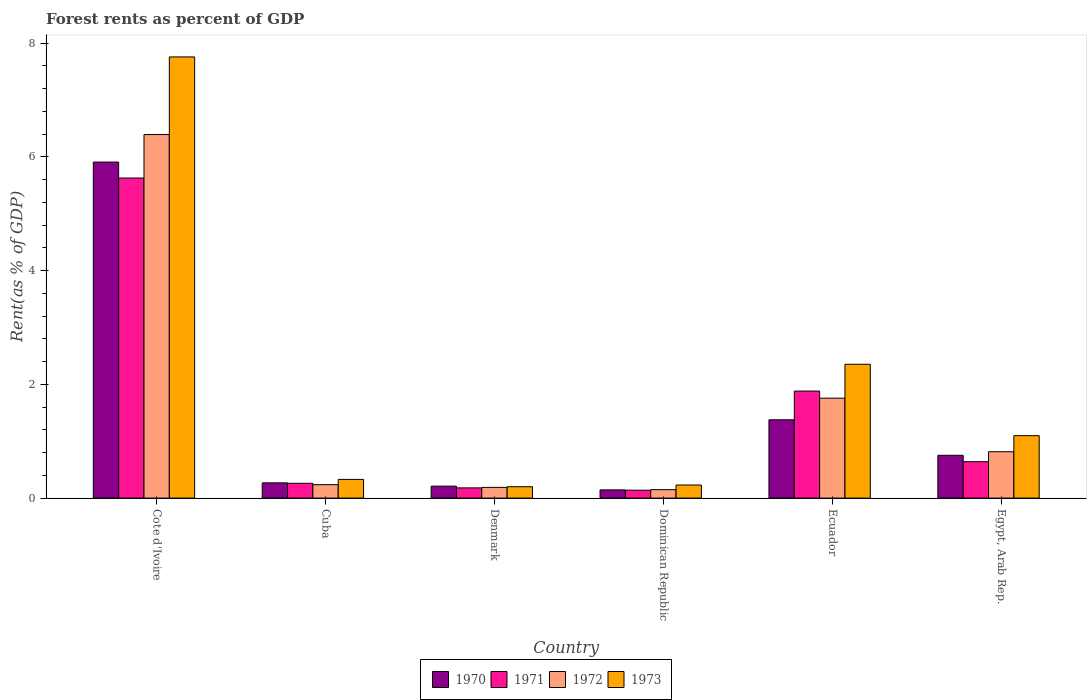How many different coloured bars are there?
Offer a very short reply. 4. How many bars are there on the 6th tick from the right?
Your answer should be very brief. 4. What is the label of the 5th group of bars from the left?
Offer a terse response. Ecuador. What is the forest rent in 1972 in Egypt, Arab Rep.?
Your answer should be compact. 0.82. Across all countries, what is the maximum forest rent in 1971?
Your answer should be compact. 5.63. Across all countries, what is the minimum forest rent in 1971?
Make the answer very short. 0.14. In which country was the forest rent in 1972 maximum?
Your answer should be very brief. Cote d'Ivoire. In which country was the forest rent in 1970 minimum?
Make the answer very short. Dominican Republic. What is the total forest rent in 1973 in the graph?
Provide a succinct answer. 11.97. What is the difference between the forest rent in 1972 in Dominican Republic and that in Ecuador?
Your response must be concise. -1.61. What is the difference between the forest rent in 1970 in Cote d'Ivoire and the forest rent in 1972 in Denmark?
Offer a very short reply. 5.72. What is the average forest rent in 1973 per country?
Your response must be concise. 1.99. What is the difference between the forest rent of/in 1970 and forest rent of/in 1971 in Dominican Republic?
Ensure brevity in your answer.  0.01. In how many countries, is the forest rent in 1972 greater than 5.2 %?
Your answer should be very brief. 1. What is the ratio of the forest rent in 1972 in Cote d'Ivoire to that in Dominican Republic?
Ensure brevity in your answer.  43.07. Is the difference between the forest rent in 1970 in Ecuador and Egypt, Arab Rep. greater than the difference between the forest rent in 1971 in Ecuador and Egypt, Arab Rep.?
Provide a short and direct response. No. What is the difference between the highest and the second highest forest rent in 1973?
Your answer should be very brief. -1.26. What is the difference between the highest and the lowest forest rent in 1972?
Offer a very short reply. 6.25. In how many countries, is the forest rent in 1972 greater than the average forest rent in 1972 taken over all countries?
Offer a very short reply. 2. Is the sum of the forest rent in 1971 in Cuba and Dominican Republic greater than the maximum forest rent in 1972 across all countries?
Your answer should be compact. No. Is it the case that in every country, the sum of the forest rent in 1973 and forest rent in 1970 is greater than the sum of forest rent in 1972 and forest rent in 1971?
Keep it short and to the point. No. What does the 4th bar from the left in Cote d'Ivoire represents?
Ensure brevity in your answer.  1973. What does the 1st bar from the right in Egypt, Arab Rep. represents?
Your answer should be compact. 1973. How many bars are there?
Offer a terse response. 24. Are all the bars in the graph horizontal?
Make the answer very short. No. How many countries are there in the graph?
Ensure brevity in your answer.  6. What is the difference between two consecutive major ticks on the Y-axis?
Offer a very short reply. 2. Are the values on the major ticks of Y-axis written in scientific E-notation?
Offer a very short reply. No. Does the graph contain any zero values?
Make the answer very short. No. Does the graph contain grids?
Ensure brevity in your answer.  No. How many legend labels are there?
Keep it short and to the point. 4. How are the legend labels stacked?
Offer a very short reply. Horizontal. What is the title of the graph?
Provide a short and direct response. Forest rents as percent of GDP. What is the label or title of the Y-axis?
Your answer should be very brief. Rent(as % of GDP). What is the Rent(as % of GDP) in 1970 in Cote d'Ivoire?
Your response must be concise. 5.91. What is the Rent(as % of GDP) of 1971 in Cote d'Ivoire?
Your response must be concise. 5.63. What is the Rent(as % of GDP) of 1972 in Cote d'Ivoire?
Make the answer very short. 6.39. What is the Rent(as % of GDP) in 1973 in Cote d'Ivoire?
Your response must be concise. 7.76. What is the Rent(as % of GDP) in 1970 in Cuba?
Give a very brief answer. 0.27. What is the Rent(as % of GDP) in 1971 in Cuba?
Your response must be concise. 0.26. What is the Rent(as % of GDP) of 1972 in Cuba?
Ensure brevity in your answer.  0.24. What is the Rent(as % of GDP) of 1973 in Cuba?
Offer a very short reply. 0.33. What is the Rent(as % of GDP) in 1970 in Denmark?
Make the answer very short. 0.21. What is the Rent(as % of GDP) of 1971 in Denmark?
Your response must be concise. 0.18. What is the Rent(as % of GDP) of 1972 in Denmark?
Offer a very short reply. 0.19. What is the Rent(as % of GDP) in 1973 in Denmark?
Offer a very short reply. 0.2. What is the Rent(as % of GDP) in 1970 in Dominican Republic?
Give a very brief answer. 0.14. What is the Rent(as % of GDP) in 1971 in Dominican Republic?
Provide a succinct answer. 0.14. What is the Rent(as % of GDP) of 1972 in Dominican Republic?
Give a very brief answer. 0.15. What is the Rent(as % of GDP) in 1973 in Dominican Republic?
Offer a very short reply. 0.23. What is the Rent(as % of GDP) of 1970 in Ecuador?
Provide a short and direct response. 1.38. What is the Rent(as % of GDP) of 1971 in Ecuador?
Your answer should be compact. 1.88. What is the Rent(as % of GDP) in 1972 in Ecuador?
Keep it short and to the point. 1.76. What is the Rent(as % of GDP) in 1973 in Ecuador?
Provide a succinct answer. 2.35. What is the Rent(as % of GDP) in 1970 in Egypt, Arab Rep.?
Provide a succinct answer. 0.75. What is the Rent(as % of GDP) of 1971 in Egypt, Arab Rep.?
Offer a very short reply. 0.64. What is the Rent(as % of GDP) in 1972 in Egypt, Arab Rep.?
Your response must be concise. 0.82. What is the Rent(as % of GDP) of 1973 in Egypt, Arab Rep.?
Provide a succinct answer. 1.1. Across all countries, what is the maximum Rent(as % of GDP) of 1970?
Give a very brief answer. 5.91. Across all countries, what is the maximum Rent(as % of GDP) of 1971?
Your response must be concise. 5.63. Across all countries, what is the maximum Rent(as % of GDP) in 1972?
Make the answer very short. 6.39. Across all countries, what is the maximum Rent(as % of GDP) of 1973?
Your response must be concise. 7.76. Across all countries, what is the minimum Rent(as % of GDP) in 1970?
Give a very brief answer. 0.14. Across all countries, what is the minimum Rent(as % of GDP) of 1971?
Your answer should be compact. 0.14. Across all countries, what is the minimum Rent(as % of GDP) of 1972?
Provide a short and direct response. 0.15. Across all countries, what is the minimum Rent(as % of GDP) in 1973?
Your response must be concise. 0.2. What is the total Rent(as % of GDP) of 1970 in the graph?
Give a very brief answer. 8.66. What is the total Rent(as % of GDP) in 1971 in the graph?
Ensure brevity in your answer.  8.73. What is the total Rent(as % of GDP) in 1972 in the graph?
Your answer should be compact. 9.54. What is the total Rent(as % of GDP) in 1973 in the graph?
Provide a short and direct response. 11.97. What is the difference between the Rent(as % of GDP) in 1970 in Cote d'Ivoire and that in Cuba?
Provide a short and direct response. 5.64. What is the difference between the Rent(as % of GDP) of 1971 in Cote d'Ivoire and that in Cuba?
Give a very brief answer. 5.37. What is the difference between the Rent(as % of GDP) in 1972 in Cote d'Ivoire and that in Cuba?
Offer a very short reply. 6.16. What is the difference between the Rent(as % of GDP) of 1973 in Cote d'Ivoire and that in Cuba?
Give a very brief answer. 7.43. What is the difference between the Rent(as % of GDP) of 1970 in Cote d'Ivoire and that in Denmark?
Offer a terse response. 5.7. What is the difference between the Rent(as % of GDP) of 1971 in Cote d'Ivoire and that in Denmark?
Your answer should be very brief. 5.45. What is the difference between the Rent(as % of GDP) of 1972 in Cote d'Ivoire and that in Denmark?
Make the answer very short. 6.21. What is the difference between the Rent(as % of GDP) in 1973 in Cote d'Ivoire and that in Denmark?
Your response must be concise. 7.56. What is the difference between the Rent(as % of GDP) of 1970 in Cote d'Ivoire and that in Dominican Republic?
Ensure brevity in your answer.  5.77. What is the difference between the Rent(as % of GDP) of 1971 in Cote d'Ivoire and that in Dominican Republic?
Give a very brief answer. 5.49. What is the difference between the Rent(as % of GDP) in 1972 in Cote d'Ivoire and that in Dominican Republic?
Your answer should be compact. 6.25. What is the difference between the Rent(as % of GDP) in 1973 in Cote d'Ivoire and that in Dominican Republic?
Ensure brevity in your answer.  7.53. What is the difference between the Rent(as % of GDP) in 1970 in Cote d'Ivoire and that in Ecuador?
Provide a succinct answer. 4.53. What is the difference between the Rent(as % of GDP) in 1971 in Cote d'Ivoire and that in Ecuador?
Ensure brevity in your answer.  3.75. What is the difference between the Rent(as % of GDP) in 1972 in Cote d'Ivoire and that in Ecuador?
Ensure brevity in your answer.  4.64. What is the difference between the Rent(as % of GDP) of 1973 in Cote d'Ivoire and that in Ecuador?
Your response must be concise. 5.41. What is the difference between the Rent(as % of GDP) in 1970 in Cote d'Ivoire and that in Egypt, Arab Rep.?
Offer a terse response. 5.16. What is the difference between the Rent(as % of GDP) in 1971 in Cote d'Ivoire and that in Egypt, Arab Rep.?
Ensure brevity in your answer.  4.99. What is the difference between the Rent(as % of GDP) of 1972 in Cote d'Ivoire and that in Egypt, Arab Rep.?
Provide a succinct answer. 5.58. What is the difference between the Rent(as % of GDP) in 1973 in Cote d'Ivoire and that in Egypt, Arab Rep.?
Provide a short and direct response. 6.66. What is the difference between the Rent(as % of GDP) in 1970 in Cuba and that in Denmark?
Your answer should be very brief. 0.06. What is the difference between the Rent(as % of GDP) of 1971 in Cuba and that in Denmark?
Offer a terse response. 0.08. What is the difference between the Rent(as % of GDP) in 1972 in Cuba and that in Denmark?
Give a very brief answer. 0.05. What is the difference between the Rent(as % of GDP) of 1973 in Cuba and that in Denmark?
Make the answer very short. 0.13. What is the difference between the Rent(as % of GDP) of 1970 in Cuba and that in Dominican Republic?
Provide a succinct answer. 0.12. What is the difference between the Rent(as % of GDP) in 1971 in Cuba and that in Dominican Republic?
Provide a short and direct response. 0.12. What is the difference between the Rent(as % of GDP) in 1972 in Cuba and that in Dominican Republic?
Ensure brevity in your answer.  0.09. What is the difference between the Rent(as % of GDP) of 1973 in Cuba and that in Dominican Republic?
Provide a short and direct response. 0.1. What is the difference between the Rent(as % of GDP) of 1970 in Cuba and that in Ecuador?
Your answer should be compact. -1.11. What is the difference between the Rent(as % of GDP) in 1971 in Cuba and that in Ecuador?
Offer a very short reply. -1.62. What is the difference between the Rent(as % of GDP) of 1972 in Cuba and that in Ecuador?
Keep it short and to the point. -1.52. What is the difference between the Rent(as % of GDP) in 1973 in Cuba and that in Ecuador?
Ensure brevity in your answer.  -2.03. What is the difference between the Rent(as % of GDP) in 1970 in Cuba and that in Egypt, Arab Rep.?
Your response must be concise. -0.48. What is the difference between the Rent(as % of GDP) of 1971 in Cuba and that in Egypt, Arab Rep.?
Your response must be concise. -0.38. What is the difference between the Rent(as % of GDP) of 1972 in Cuba and that in Egypt, Arab Rep.?
Offer a very short reply. -0.58. What is the difference between the Rent(as % of GDP) in 1973 in Cuba and that in Egypt, Arab Rep.?
Ensure brevity in your answer.  -0.77. What is the difference between the Rent(as % of GDP) in 1970 in Denmark and that in Dominican Republic?
Offer a very short reply. 0.07. What is the difference between the Rent(as % of GDP) of 1971 in Denmark and that in Dominican Republic?
Your answer should be very brief. 0.04. What is the difference between the Rent(as % of GDP) in 1972 in Denmark and that in Dominican Republic?
Offer a very short reply. 0.04. What is the difference between the Rent(as % of GDP) in 1973 in Denmark and that in Dominican Republic?
Keep it short and to the point. -0.03. What is the difference between the Rent(as % of GDP) of 1970 in Denmark and that in Ecuador?
Your answer should be compact. -1.17. What is the difference between the Rent(as % of GDP) of 1971 in Denmark and that in Ecuador?
Offer a terse response. -1.7. What is the difference between the Rent(as % of GDP) in 1972 in Denmark and that in Ecuador?
Make the answer very short. -1.57. What is the difference between the Rent(as % of GDP) of 1973 in Denmark and that in Ecuador?
Your answer should be very brief. -2.15. What is the difference between the Rent(as % of GDP) in 1970 in Denmark and that in Egypt, Arab Rep.?
Give a very brief answer. -0.54. What is the difference between the Rent(as % of GDP) of 1971 in Denmark and that in Egypt, Arab Rep.?
Your response must be concise. -0.46. What is the difference between the Rent(as % of GDP) of 1972 in Denmark and that in Egypt, Arab Rep.?
Offer a terse response. -0.63. What is the difference between the Rent(as % of GDP) in 1973 in Denmark and that in Egypt, Arab Rep.?
Offer a terse response. -0.9. What is the difference between the Rent(as % of GDP) of 1970 in Dominican Republic and that in Ecuador?
Provide a short and direct response. -1.23. What is the difference between the Rent(as % of GDP) of 1971 in Dominican Republic and that in Ecuador?
Your answer should be compact. -1.74. What is the difference between the Rent(as % of GDP) in 1972 in Dominican Republic and that in Ecuador?
Your answer should be very brief. -1.61. What is the difference between the Rent(as % of GDP) in 1973 in Dominican Republic and that in Ecuador?
Your answer should be compact. -2.12. What is the difference between the Rent(as % of GDP) in 1970 in Dominican Republic and that in Egypt, Arab Rep.?
Your response must be concise. -0.61. What is the difference between the Rent(as % of GDP) of 1971 in Dominican Republic and that in Egypt, Arab Rep.?
Provide a short and direct response. -0.5. What is the difference between the Rent(as % of GDP) of 1972 in Dominican Republic and that in Egypt, Arab Rep.?
Your response must be concise. -0.67. What is the difference between the Rent(as % of GDP) of 1973 in Dominican Republic and that in Egypt, Arab Rep.?
Your answer should be very brief. -0.87. What is the difference between the Rent(as % of GDP) of 1970 in Ecuador and that in Egypt, Arab Rep.?
Your answer should be compact. 0.62. What is the difference between the Rent(as % of GDP) of 1971 in Ecuador and that in Egypt, Arab Rep.?
Provide a succinct answer. 1.24. What is the difference between the Rent(as % of GDP) in 1972 in Ecuador and that in Egypt, Arab Rep.?
Keep it short and to the point. 0.94. What is the difference between the Rent(as % of GDP) of 1973 in Ecuador and that in Egypt, Arab Rep.?
Offer a very short reply. 1.26. What is the difference between the Rent(as % of GDP) in 1970 in Cote d'Ivoire and the Rent(as % of GDP) in 1971 in Cuba?
Give a very brief answer. 5.65. What is the difference between the Rent(as % of GDP) of 1970 in Cote d'Ivoire and the Rent(as % of GDP) of 1972 in Cuba?
Offer a terse response. 5.67. What is the difference between the Rent(as % of GDP) in 1970 in Cote d'Ivoire and the Rent(as % of GDP) in 1973 in Cuba?
Offer a terse response. 5.58. What is the difference between the Rent(as % of GDP) of 1971 in Cote d'Ivoire and the Rent(as % of GDP) of 1972 in Cuba?
Your answer should be compact. 5.39. What is the difference between the Rent(as % of GDP) of 1971 in Cote d'Ivoire and the Rent(as % of GDP) of 1973 in Cuba?
Your answer should be compact. 5.3. What is the difference between the Rent(as % of GDP) in 1972 in Cote d'Ivoire and the Rent(as % of GDP) in 1973 in Cuba?
Make the answer very short. 6.07. What is the difference between the Rent(as % of GDP) in 1970 in Cote d'Ivoire and the Rent(as % of GDP) in 1971 in Denmark?
Your answer should be very brief. 5.73. What is the difference between the Rent(as % of GDP) of 1970 in Cote d'Ivoire and the Rent(as % of GDP) of 1972 in Denmark?
Provide a succinct answer. 5.72. What is the difference between the Rent(as % of GDP) in 1970 in Cote d'Ivoire and the Rent(as % of GDP) in 1973 in Denmark?
Your answer should be compact. 5.71. What is the difference between the Rent(as % of GDP) of 1971 in Cote d'Ivoire and the Rent(as % of GDP) of 1972 in Denmark?
Keep it short and to the point. 5.44. What is the difference between the Rent(as % of GDP) in 1971 in Cote d'Ivoire and the Rent(as % of GDP) in 1973 in Denmark?
Your response must be concise. 5.43. What is the difference between the Rent(as % of GDP) of 1972 in Cote d'Ivoire and the Rent(as % of GDP) of 1973 in Denmark?
Offer a very short reply. 6.19. What is the difference between the Rent(as % of GDP) in 1970 in Cote d'Ivoire and the Rent(as % of GDP) in 1971 in Dominican Republic?
Keep it short and to the point. 5.77. What is the difference between the Rent(as % of GDP) in 1970 in Cote d'Ivoire and the Rent(as % of GDP) in 1972 in Dominican Republic?
Provide a succinct answer. 5.76. What is the difference between the Rent(as % of GDP) of 1970 in Cote d'Ivoire and the Rent(as % of GDP) of 1973 in Dominican Republic?
Your response must be concise. 5.68. What is the difference between the Rent(as % of GDP) of 1971 in Cote d'Ivoire and the Rent(as % of GDP) of 1972 in Dominican Republic?
Give a very brief answer. 5.48. What is the difference between the Rent(as % of GDP) of 1971 in Cote d'Ivoire and the Rent(as % of GDP) of 1973 in Dominican Republic?
Your answer should be very brief. 5.4. What is the difference between the Rent(as % of GDP) of 1972 in Cote d'Ivoire and the Rent(as % of GDP) of 1973 in Dominican Republic?
Your response must be concise. 6.16. What is the difference between the Rent(as % of GDP) in 1970 in Cote d'Ivoire and the Rent(as % of GDP) in 1971 in Ecuador?
Provide a succinct answer. 4.03. What is the difference between the Rent(as % of GDP) of 1970 in Cote d'Ivoire and the Rent(as % of GDP) of 1972 in Ecuador?
Give a very brief answer. 4.15. What is the difference between the Rent(as % of GDP) in 1970 in Cote d'Ivoire and the Rent(as % of GDP) in 1973 in Ecuador?
Ensure brevity in your answer.  3.56. What is the difference between the Rent(as % of GDP) of 1971 in Cote d'Ivoire and the Rent(as % of GDP) of 1972 in Ecuador?
Keep it short and to the point. 3.87. What is the difference between the Rent(as % of GDP) of 1971 in Cote d'Ivoire and the Rent(as % of GDP) of 1973 in Ecuador?
Keep it short and to the point. 3.28. What is the difference between the Rent(as % of GDP) in 1972 in Cote d'Ivoire and the Rent(as % of GDP) in 1973 in Ecuador?
Your answer should be compact. 4.04. What is the difference between the Rent(as % of GDP) in 1970 in Cote d'Ivoire and the Rent(as % of GDP) in 1971 in Egypt, Arab Rep.?
Ensure brevity in your answer.  5.27. What is the difference between the Rent(as % of GDP) in 1970 in Cote d'Ivoire and the Rent(as % of GDP) in 1972 in Egypt, Arab Rep.?
Give a very brief answer. 5.09. What is the difference between the Rent(as % of GDP) of 1970 in Cote d'Ivoire and the Rent(as % of GDP) of 1973 in Egypt, Arab Rep.?
Your answer should be very brief. 4.81. What is the difference between the Rent(as % of GDP) of 1971 in Cote d'Ivoire and the Rent(as % of GDP) of 1972 in Egypt, Arab Rep.?
Your response must be concise. 4.81. What is the difference between the Rent(as % of GDP) in 1971 in Cote d'Ivoire and the Rent(as % of GDP) in 1973 in Egypt, Arab Rep.?
Your answer should be very brief. 4.53. What is the difference between the Rent(as % of GDP) in 1972 in Cote d'Ivoire and the Rent(as % of GDP) in 1973 in Egypt, Arab Rep.?
Your response must be concise. 5.3. What is the difference between the Rent(as % of GDP) of 1970 in Cuba and the Rent(as % of GDP) of 1971 in Denmark?
Your answer should be compact. 0.09. What is the difference between the Rent(as % of GDP) of 1970 in Cuba and the Rent(as % of GDP) of 1972 in Denmark?
Provide a short and direct response. 0.08. What is the difference between the Rent(as % of GDP) in 1970 in Cuba and the Rent(as % of GDP) in 1973 in Denmark?
Provide a succinct answer. 0.07. What is the difference between the Rent(as % of GDP) of 1971 in Cuba and the Rent(as % of GDP) of 1972 in Denmark?
Your answer should be very brief. 0.07. What is the difference between the Rent(as % of GDP) of 1971 in Cuba and the Rent(as % of GDP) of 1973 in Denmark?
Ensure brevity in your answer.  0.06. What is the difference between the Rent(as % of GDP) of 1972 in Cuba and the Rent(as % of GDP) of 1973 in Denmark?
Keep it short and to the point. 0.04. What is the difference between the Rent(as % of GDP) in 1970 in Cuba and the Rent(as % of GDP) in 1971 in Dominican Republic?
Keep it short and to the point. 0.13. What is the difference between the Rent(as % of GDP) of 1970 in Cuba and the Rent(as % of GDP) of 1972 in Dominican Republic?
Provide a succinct answer. 0.12. What is the difference between the Rent(as % of GDP) of 1970 in Cuba and the Rent(as % of GDP) of 1973 in Dominican Republic?
Provide a short and direct response. 0.04. What is the difference between the Rent(as % of GDP) in 1971 in Cuba and the Rent(as % of GDP) in 1972 in Dominican Republic?
Your answer should be compact. 0.11. What is the difference between the Rent(as % of GDP) of 1971 in Cuba and the Rent(as % of GDP) of 1973 in Dominican Republic?
Your answer should be very brief. 0.03. What is the difference between the Rent(as % of GDP) in 1972 in Cuba and the Rent(as % of GDP) in 1973 in Dominican Republic?
Your answer should be very brief. 0.01. What is the difference between the Rent(as % of GDP) in 1970 in Cuba and the Rent(as % of GDP) in 1971 in Ecuador?
Your response must be concise. -1.61. What is the difference between the Rent(as % of GDP) of 1970 in Cuba and the Rent(as % of GDP) of 1972 in Ecuador?
Make the answer very short. -1.49. What is the difference between the Rent(as % of GDP) in 1970 in Cuba and the Rent(as % of GDP) in 1973 in Ecuador?
Offer a very short reply. -2.09. What is the difference between the Rent(as % of GDP) in 1971 in Cuba and the Rent(as % of GDP) in 1972 in Ecuador?
Make the answer very short. -1.5. What is the difference between the Rent(as % of GDP) in 1971 in Cuba and the Rent(as % of GDP) in 1973 in Ecuador?
Provide a short and direct response. -2.09. What is the difference between the Rent(as % of GDP) of 1972 in Cuba and the Rent(as % of GDP) of 1973 in Ecuador?
Offer a terse response. -2.12. What is the difference between the Rent(as % of GDP) of 1970 in Cuba and the Rent(as % of GDP) of 1971 in Egypt, Arab Rep.?
Offer a very short reply. -0.37. What is the difference between the Rent(as % of GDP) in 1970 in Cuba and the Rent(as % of GDP) in 1972 in Egypt, Arab Rep.?
Your answer should be compact. -0.55. What is the difference between the Rent(as % of GDP) of 1970 in Cuba and the Rent(as % of GDP) of 1973 in Egypt, Arab Rep.?
Your answer should be compact. -0.83. What is the difference between the Rent(as % of GDP) of 1971 in Cuba and the Rent(as % of GDP) of 1972 in Egypt, Arab Rep.?
Make the answer very short. -0.56. What is the difference between the Rent(as % of GDP) in 1971 in Cuba and the Rent(as % of GDP) in 1973 in Egypt, Arab Rep.?
Your response must be concise. -0.84. What is the difference between the Rent(as % of GDP) in 1972 in Cuba and the Rent(as % of GDP) in 1973 in Egypt, Arab Rep.?
Offer a terse response. -0.86. What is the difference between the Rent(as % of GDP) of 1970 in Denmark and the Rent(as % of GDP) of 1971 in Dominican Republic?
Your answer should be compact. 0.07. What is the difference between the Rent(as % of GDP) in 1970 in Denmark and the Rent(as % of GDP) in 1972 in Dominican Republic?
Keep it short and to the point. 0.06. What is the difference between the Rent(as % of GDP) in 1970 in Denmark and the Rent(as % of GDP) in 1973 in Dominican Republic?
Make the answer very short. -0.02. What is the difference between the Rent(as % of GDP) in 1971 in Denmark and the Rent(as % of GDP) in 1972 in Dominican Republic?
Keep it short and to the point. 0.03. What is the difference between the Rent(as % of GDP) of 1971 in Denmark and the Rent(as % of GDP) of 1973 in Dominican Republic?
Your answer should be very brief. -0.05. What is the difference between the Rent(as % of GDP) of 1972 in Denmark and the Rent(as % of GDP) of 1973 in Dominican Republic?
Make the answer very short. -0.04. What is the difference between the Rent(as % of GDP) of 1970 in Denmark and the Rent(as % of GDP) of 1971 in Ecuador?
Ensure brevity in your answer.  -1.67. What is the difference between the Rent(as % of GDP) of 1970 in Denmark and the Rent(as % of GDP) of 1972 in Ecuador?
Offer a very short reply. -1.55. What is the difference between the Rent(as % of GDP) in 1970 in Denmark and the Rent(as % of GDP) in 1973 in Ecuador?
Provide a short and direct response. -2.14. What is the difference between the Rent(as % of GDP) of 1971 in Denmark and the Rent(as % of GDP) of 1972 in Ecuador?
Your answer should be very brief. -1.58. What is the difference between the Rent(as % of GDP) in 1971 in Denmark and the Rent(as % of GDP) in 1973 in Ecuador?
Your response must be concise. -2.17. What is the difference between the Rent(as % of GDP) in 1972 in Denmark and the Rent(as % of GDP) in 1973 in Ecuador?
Your answer should be compact. -2.17. What is the difference between the Rent(as % of GDP) in 1970 in Denmark and the Rent(as % of GDP) in 1971 in Egypt, Arab Rep.?
Offer a very short reply. -0.43. What is the difference between the Rent(as % of GDP) of 1970 in Denmark and the Rent(as % of GDP) of 1972 in Egypt, Arab Rep.?
Your answer should be compact. -0.61. What is the difference between the Rent(as % of GDP) in 1970 in Denmark and the Rent(as % of GDP) in 1973 in Egypt, Arab Rep.?
Ensure brevity in your answer.  -0.89. What is the difference between the Rent(as % of GDP) in 1971 in Denmark and the Rent(as % of GDP) in 1972 in Egypt, Arab Rep.?
Keep it short and to the point. -0.64. What is the difference between the Rent(as % of GDP) of 1971 in Denmark and the Rent(as % of GDP) of 1973 in Egypt, Arab Rep.?
Offer a terse response. -0.92. What is the difference between the Rent(as % of GDP) of 1972 in Denmark and the Rent(as % of GDP) of 1973 in Egypt, Arab Rep.?
Provide a succinct answer. -0.91. What is the difference between the Rent(as % of GDP) of 1970 in Dominican Republic and the Rent(as % of GDP) of 1971 in Ecuador?
Offer a very short reply. -1.74. What is the difference between the Rent(as % of GDP) of 1970 in Dominican Republic and the Rent(as % of GDP) of 1972 in Ecuador?
Provide a succinct answer. -1.61. What is the difference between the Rent(as % of GDP) of 1970 in Dominican Republic and the Rent(as % of GDP) of 1973 in Ecuador?
Your response must be concise. -2.21. What is the difference between the Rent(as % of GDP) in 1971 in Dominican Republic and the Rent(as % of GDP) in 1972 in Ecuador?
Offer a very short reply. -1.62. What is the difference between the Rent(as % of GDP) in 1971 in Dominican Republic and the Rent(as % of GDP) in 1973 in Ecuador?
Offer a terse response. -2.22. What is the difference between the Rent(as % of GDP) in 1972 in Dominican Republic and the Rent(as % of GDP) in 1973 in Ecuador?
Give a very brief answer. -2.21. What is the difference between the Rent(as % of GDP) of 1970 in Dominican Republic and the Rent(as % of GDP) of 1971 in Egypt, Arab Rep.?
Keep it short and to the point. -0.5. What is the difference between the Rent(as % of GDP) of 1970 in Dominican Republic and the Rent(as % of GDP) of 1972 in Egypt, Arab Rep.?
Keep it short and to the point. -0.67. What is the difference between the Rent(as % of GDP) in 1970 in Dominican Republic and the Rent(as % of GDP) in 1973 in Egypt, Arab Rep.?
Ensure brevity in your answer.  -0.95. What is the difference between the Rent(as % of GDP) in 1971 in Dominican Republic and the Rent(as % of GDP) in 1972 in Egypt, Arab Rep.?
Your answer should be compact. -0.68. What is the difference between the Rent(as % of GDP) in 1971 in Dominican Republic and the Rent(as % of GDP) in 1973 in Egypt, Arab Rep.?
Make the answer very short. -0.96. What is the difference between the Rent(as % of GDP) in 1972 in Dominican Republic and the Rent(as % of GDP) in 1973 in Egypt, Arab Rep.?
Ensure brevity in your answer.  -0.95. What is the difference between the Rent(as % of GDP) in 1970 in Ecuador and the Rent(as % of GDP) in 1971 in Egypt, Arab Rep.?
Offer a very short reply. 0.74. What is the difference between the Rent(as % of GDP) of 1970 in Ecuador and the Rent(as % of GDP) of 1972 in Egypt, Arab Rep.?
Your answer should be compact. 0.56. What is the difference between the Rent(as % of GDP) of 1970 in Ecuador and the Rent(as % of GDP) of 1973 in Egypt, Arab Rep.?
Provide a succinct answer. 0.28. What is the difference between the Rent(as % of GDP) of 1971 in Ecuador and the Rent(as % of GDP) of 1972 in Egypt, Arab Rep.?
Provide a succinct answer. 1.07. What is the difference between the Rent(as % of GDP) of 1971 in Ecuador and the Rent(as % of GDP) of 1973 in Egypt, Arab Rep.?
Give a very brief answer. 0.78. What is the difference between the Rent(as % of GDP) in 1972 in Ecuador and the Rent(as % of GDP) in 1973 in Egypt, Arab Rep.?
Offer a very short reply. 0.66. What is the average Rent(as % of GDP) of 1970 per country?
Provide a succinct answer. 1.44. What is the average Rent(as % of GDP) of 1971 per country?
Your response must be concise. 1.46. What is the average Rent(as % of GDP) in 1972 per country?
Offer a terse response. 1.59. What is the average Rent(as % of GDP) in 1973 per country?
Ensure brevity in your answer.  2. What is the difference between the Rent(as % of GDP) in 1970 and Rent(as % of GDP) in 1971 in Cote d'Ivoire?
Keep it short and to the point. 0.28. What is the difference between the Rent(as % of GDP) of 1970 and Rent(as % of GDP) of 1972 in Cote d'Ivoire?
Provide a short and direct response. -0.48. What is the difference between the Rent(as % of GDP) in 1970 and Rent(as % of GDP) in 1973 in Cote d'Ivoire?
Keep it short and to the point. -1.85. What is the difference between the Rent(as % of GDP) in 1971 and Rent(as % of GDP) in 1972 in Cote d'Ivoire?
Provide a succinct answer. -0.76. What is the difference between the Rent(as % of GDP) in 1971 and Rent(as % of GDP) in 1973 in Cote d'Ivoire?
Your response must be concise. -2.13. What is the difference between the Rent(as % of GDP) in 1972 and Rent(as % of GDP) in 1973 in Cote d'Ivoire?
Your response must be concise. -1.36. What is the difference between the Rent(as % of GDP) in 1970 and Rent(as % of GDP) in 1971 in Cuba?
Make the answer very short. 0.01. What is the difference between the Rent(as % of GDP) in 1970 and Rent(as % of GDP) in 1972 in Cuba?
Make the answer very short. 0.03. What is the difference between the Rent(as % of GDP) in 1970 and Rent(as % of GDP) in 1973 in Cuba?
Ensure brevity in your answer.  -0.06. What is the difference between the Rent(as % of GDP) in 1971 and Rent(as % of GDP) in 1972 in Cuba?
Your answer should be very brief. 0.02. What is the difference between the Rent(as % of GDP) of 1971 and Rent(as % of GDP) of 1973 in Cuba?
Provide a succinct answer. -0.07. What is the difference between the Rent(as % of GDP) of 1972 and Rent(as % of GDP) of 1973 in Cuba?
Provide a succinct answer. -0.09. What is the difference between the Rent(as % of GDP) in 1970 and Rent(as % of GDP) in 1971 in Denmark?
Provide a succinct answer. 0.03. What is the difference between the Rent(as % of GDP) in 1970 and Rent(as % of GDP) in 1972 in Denmark?
Provide a short and direct response. 0.02. What is the difference between the Rent(as % of GDP) of 1970 and Rent(as % of GDP) of 1973 in Denmark?
Your answer should be very brief. 0.01. What is the difference between the Rent(as % of GDP) of 1971 and Rent(as % of GDP) of 1972 in Denmark?
Your answer should be very brief. -0.01. What is the difference between the Rent(as % of GDP) in 1971 and Rent(as % of GDP) in 1973 in Denmark?
Ensure brevity in your answer.  -0.02. What is the difference between the Rent(as % of GDP) of 1972 and Rent(as % of GDP) of 1973 in Denmark?
Offer a very short reply. -0.01. What is the difference between the Rent(as % of GDP) of 1970 and Rent(as % of GDP) of 1971 in Dominican Republic?
Provide a succinct answer. 0.01. What is the difference between the Rent(as % of GDP) of 1970 and Rent(as % of GDP) of 1972 in Dominican Republic?
Offer a terse response. -0. What is the difference between the Rent(as % of GDP) in 1970 and Rent(as % of GDP) in 1973 in Dominican Republic?
Make the answer very short. -0.09. What is the difference between the Rent(as % of GDP) in 1971 and Rent(as % of GDP) in 1972 in Dominican Republic?
Ensure brevity in your answer.  -0.01. What is the difference between the Rent(as % of GDP) of 1971 and Rent(as % of GDP) of 1973 in Dominican Republic?
Your answer should be very brief. -0.09. What is the difference between the Rent(as % of GDP) in 1972 and Rent(as % of GDP) in 1973 in Dominican Republic?
Your answer should be compact. -0.08. What is the difference between the Rent(as % of GDP) in 1970 and Rent(as % of GDP) in 1971 in Ecuador?
Keep it short and to the point. -0.51. What is the difference between the Rent(as % of GDP) in 1970 and Rent(as % of GDP) in 1972 in Ecuador?
Your response must be concise. -0.38. What is the difference between the Rent(as % of GDP) in 1970 and Rent(as % of GDP) in 1973 in Ecuador?
Provide a short and direct response. -0.98. What is the difference between the Rent(as % of GDP) in 1971 and Rent(as % of GDP) in 1972 in Ecuador?
Offer a very short reply. 0.12. What is the difference between the Rent(as % of GDP) of 1971 and Rent(as % of GDP) of 1973 in Ecuador?
Give a very brief answer. -0.47. What is the difference between the Rent(as % of GDP) of 1972 and Rent(as % of GDP) of 1973 in Ecuador?
Provide a succinct answer. -0.6. What is the difference between the Rent(as % of GDP) in 1970 and Rent(as % of GDP) in 1971 in Egypt, Arab Rep.?
Offer a very short reply. 0.11. What is the difference between the Rent(as % of GDP) of 1970 and Rent(as % of GDP) of 1972 in Egypt, Arab Rep.?
Make the answer very short. -0.06. What is the difference between the Rent(as % of GDP) in 1970 and Rent(as % of GDP) in 1973 in Egypt, Arab Rep.?
Give a very brief answer. -0.35. What is the difference between the Rent(as % of GDP) in 1971 and Rent(as % of GDP) in 1972 in Egypt, Arab Rep.?
Give a very brief answer. -0.18. What is the difference between the Rent(as % of GDP) of 1971 and Rent(as % of GDP) of 1973 in Egypt, Arab Rep.?
Your response must be concise. -0.46. What is the difference between the Rent(as % of GDP) in 1972 and Rent(as % of GDP) in 1973 in Egypt, Arab Rep.?
Provide a short and direct response. -0.28. What is the ratio of the Rent(as % of GDP) of 1970 in Cote d'Ivoire to that in Cuba?
Offer a terse response. 22.06. What is the ratio of the Rent(as % of GDP) of 1971 in Cote d'Ivoire to that in Cuba?
Provide a succinct answer. 21.63. What is the ratio of the Rent(as % of GDP) in 1972 in Cote d'Ivoire to that in Cuba?
Your response must be concise. 27.11. What is the ratio of the Rent(as % of GDP) of 1973 in Cote d'Ivoire to that in Cuba?
Provide a succinct answer. 23.6. What is the ratio of the Rent(as % of GDP) in 1970 in Cote d'Ivoire to that in Denmark?
Offer a terse response. 28.17. What is the ratio of the Rent(as % of GDP) of 1971 in Cote d'Ivoire to that in Denmark?
Provide a succinct answer. 31.34. What is the ratio of the Rent(as % of GDP) in 1972 in Cote d'Ivoire to that in Denmark?
Your answer should be very brief. 33.93. What is the ratio of the Rent(as % of GDP) of 1973 in Cote d'Ivoire to that in Denmark?
Provide a short and direct response. 38.81. What is the ratio of the Rent(as % of GDP) in 1970 in Cote d'Ivoire to that in Dominican Republic?
Offer a very short reply. 41.04. What is the ratio of the Rent(as % of GDP) of 1971 in Cote d'Ivoire to that in Dominican Republic?
Keep it short and to the point. 40.55. What is the ratio of the Rent(as % of GDP) in 1972 in Cote d'Ivoire to that in Dominican Republic?
Make the answer very short. 43.07. What is the ratio of the Rent(as % of GDP) in 1973 in Cote d'Ivoire to that in Dominican Republic?
Ensure brevity in your answer.  33.75. What is the ratio of the Rent(as % of GDP) of 1970 in Cote d'Ivoire to that in Ecuador?
Provide a short and direct response. 4.29. What is the ratio of the Rent(as % of GDP) of 1971 in Cote d'Ivoire to that in Ecuador?
Offer a very short reply. 2.99. What is the ratio of the Rent(as % of GDP) in 1972 in Cote d'Ivoire to that in Ecuador?
Keep it short and to the point. 3.64. What is the ratio of the Rent(as % of GDP) of 1973 in Cote d'Ivoire to that in Ecuador?
Provide a short and direct response. 3.3. What is the ratio of the Rent(as % of GDP) in 1970 in Cote d'Ivoire to that in Egypt, Arab Rep.?
Your answer should be very brief. 7.85. What is the ratio of the Rent(as % of GDP) of 1971 in Cote d'Ivoire to that in Egypt, Arab Rep.?
Your response must be concise. 8.79. What is the ratio of the Rent(as % of GDP) in 1972 in Cote d'Ivoire to that in Egypt, Arab Rep.?
Your response must be concise. 7.84. What is the ratio of the Rent(as % of GDP) in 1973 in Cote d'Ivoire to that in Egypt, Arab Rep.?
Your response must be concise. 7.07. What is the ratio of the Rent(as % of GDP) of 1970 in Cuba to that in Denmark?
Ensure brevity in your answer.  1.28. What is the ratio of the Rent(as % of GDP) in 1971 in Cuba to that in Denmark?
Your answer should be compact. 1.45. What is the ratio of the Rent(as % of GDP) of 1972 in Cuba to that in Denmark?
Offer a very short reply. 1.25. What is the ratio of the Rent(as % of GDP) in 1973 in Cuba to that in Denmark?
Your answer should be compact. 1.64. What is the ratio of the Rent(as % of GDP) of 1970 in Cuba to that in Dominican Republic?
Your response must be concise. 1.86. What is the ratio of the Rent(as % of GDP) of 1971 in Cuba to that in Dominican Republic?
Offer a very short reply. 1.87. What is the ratio of the Rent(as % of GDP) in 1972 in Cuba to that in Dominican Republic?
Your answer should be compact. 1.59. What is the ratio of the Rent(as % of GDP) in 1973 in Cuba to that in Dominican Republic?
Provide a short and direct response. 1.43. What is the ratio of the Rent(as % of GDP) of 1970 in Cuba to that in Ecuador?
Provide a succinct answer. 0.19. What is the ratio of the Rent(as % of GDP) in 1971 in Cuba to that in Ecuador?
Keep it short and to the point. 0.14. What is the ratio of the Rent(as % of GDP) of 1972 in Cuba to that in Ecuador?
Offer a very short reply. 0.13. What is the ratio of the Rent(as % of GDP) in 1973 in Cuba to that in Ecuador?
Your response must be concise. 0.14. What is the ratio of the Rent(as % of GDP) of 1970 in Cuba to that in Egypt, Arab Rep.?
Make the answer very short. 0.36. What is the ratio of the Rent(as % of GDP) in 1971 in Cuba to that in Egypt, Arab Rep.?
Your answer should be very brief. 0.41. What is the ratio of the Rent(as % of GDP) of 1972 in Cuba to that in Egypt, Arab Rep.?
Provide a short and direct response. 0.29. What is the ratio of the Rent(as % of GDP) of 1973 in Cuba to that in Egypt, Arab Rep.?
Offer a terse response. 0.3. What is the ratio of the Rent(as % of GDP) in 1970 in Denmark to that in Dominican Republic?
Provide a short and direct response. 1.46. What is the ratio of the Rent(as % of GDP) in 1971 in Denmark to that in Dominican Republic?
Provide a succinct answer. 1.29. What is the ratio of the Rent(as % of GDP) of 1972 in Denmark to that in Dominican Republic?
Your answer should be very brief. 1.27. What is the ratio of the Rent(as % of GDP) in 1973 in Denmark to that in Dominican Republic?
Provide a short and direct response. 0.87. What is the ratio of the Rent(as % of GDP) of 1970 in Denmark to that in Ecuador?
Provide a succinct answer. 0.15. What is the ratio of the Rent(as % of GDP) in 1971 in Denmark to that in Ecuador?
Offer a very short reply. 0.1. What is the ratio of the Rent(as % of GDP) of 1972 in Denmark to that in Ecuador?
Your answer should be very brief. 0.11. What is the ratio of the Rent(as % of GDP) in 1973 in Denmark to that in Ecuador?
Offer a terse response. 0.08. What is the ratio of the Rent(as % of GDP) in 1970 in Denmark to that in Egypt, Arab Rep.?
Your answer should be compact. 0.28. What is the ratio of the Rent(as % of GDP) in 1971 in Denmark to that in Egypt, Arab Rep.?
Provide a succinct answer. 0.28. What is the ratio of the Rent(as % of GDP) in 1972 in Denmark to that in Egypt, Arab Rep.?
Make the answer very short. 0.23. What is the ratio of the Rent(as % of GDP) of 1973 in Denmark to that in Egypt, Arab Rep.?
Your answer should be compact. 0.18. What is the ratio of the Rent(as % of GDP) in 1970 in Dominican Republic to that in Ecuador?
Provide a short and direct response. 0.1. What is the ratio of the Rent(as % of GDP) of 1971 in Dominican Republic to that in Ecuador?
Your answer should be very brief. 0.07. What is the ratio of the Rent(as % of GDP) of 1972 in Dominican Republic to that in Ecuador?
Ensure brevity in your answer.  0.08. What is the ratio of the Rent(as % of GDP) of 1973 in Dominican Republic to that in Ecuador?
Ensure brevity in your answer.  0.1. What is the ratio of the Rent(as % of GDP) of 1970 in Dominican Republic to that in Egypt, Arab Rep.?
Your response must be concise. 0.19. What is the ratio of the Rent(as % of GDP) of 1971 in Dominican Republic to that in Egypt, Arab Rep.?
Offer a very short reply. 0.22. What is the ratio of the Rent(as % of GDP) of 1972 in Dominican Republic to that in Egypt, Arab Rep.?
Your answer should be very brief. 0.18. What is the ratio of the Rent(as % of GDP) of 1973 in Dominican Republic to that in Egypt, Arab Rep.?
Your answer should be very brief. 0.21. What is the ratio of the Rent(as % of GDP) in 1970 in Ecuador to that in Egypt, Arab Rep.?
Keep it short and to the point. 1.83. What is the ratio of the Rent(as % of GDP) of 1971 in Ecuador to that in Egypt, Arab Rep.?
Keep it short and to the point. 2.94. What is the ratio of the Rent(as % of GDP) in 1972 in Ecuador to that in Egypt, Arab Rep.?
Give a very brief answer. 2.16. What is the ratio of the Rent(as % of GDP) of 1973 in Ecuador to that in Egypt, Arab Rep.?
Offer a very short reply. 2.14. What is the difference between the highest and the second highest Rent(as % of GDP) in 1970?
Ensure brevity in your answer.  4.53. What is the difference between the highest and the second highest Rent(as % of GDP) of 1971?
Offer a terse response. 3.75. What is the difference between the highest and the second highest Rent(as % of GDP) of 1972?
Your answer should be very brief. 4.64. What is the difference between the highest and the second highest Rent(as % of GDP) of 1973?
Your answer should be very brief. 5.41. What is the difference between the highest and the lowest Rent(as % of GDP) of 1970?
Make the answer very short. 5.77. What is the difference between the highest and the lowest Rent(as % of GDP) of 1971?
Make the answer very short. 5.49. What is the difference between the highest and the lowest Rent(as % of GDP) in 1972?
Your answer should be very brief. 6.25. What is the difference between the highest and the lowest Rent(as % of GDP) in 1973?
Provide a succinct answer. 7.56. 